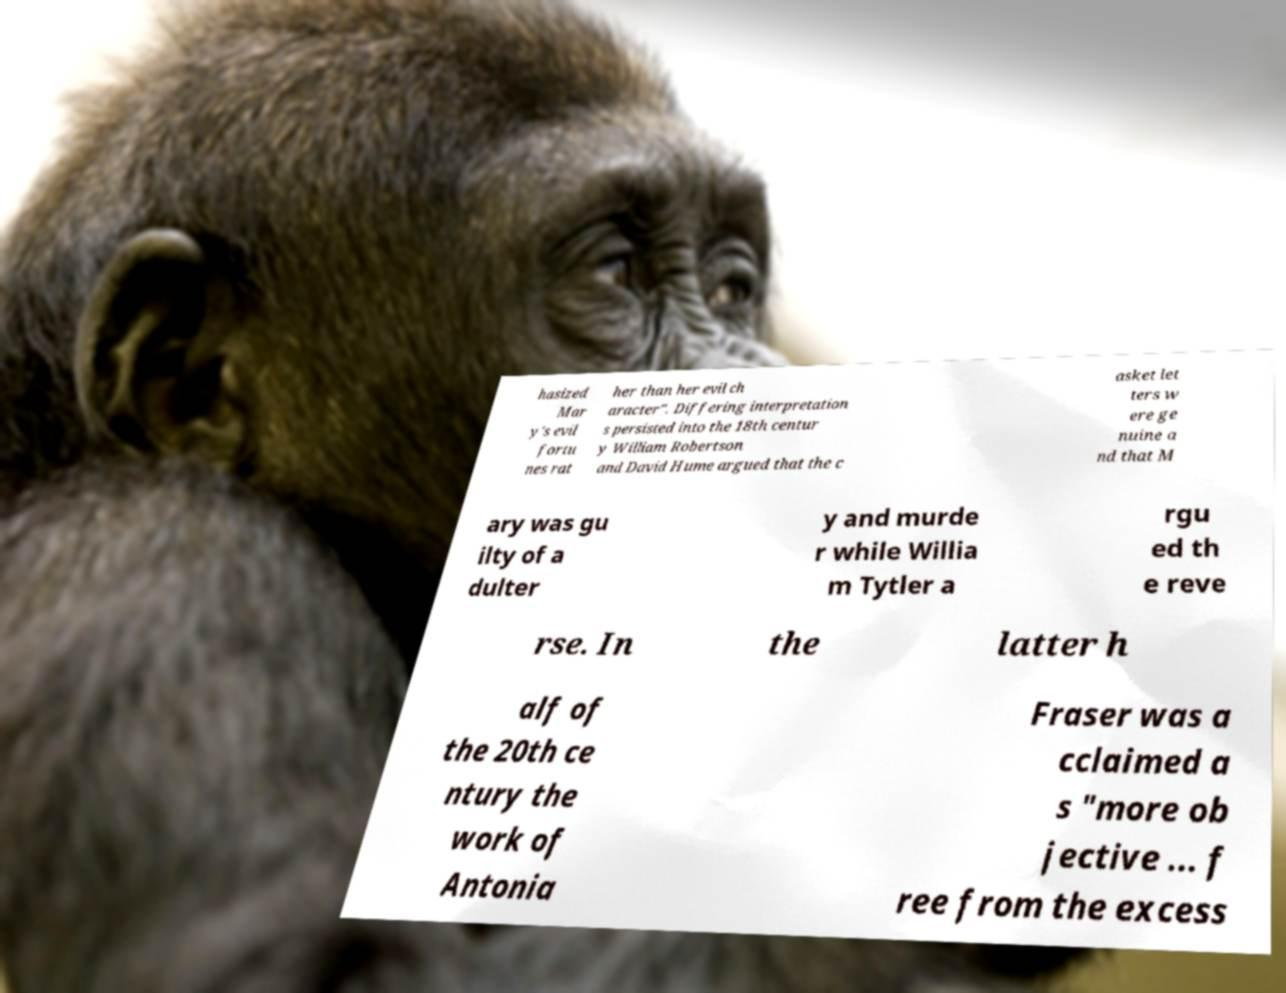Could you extract and type out the text from this image? hasized Mar y's evil fortu nes rat her than her evil ch aracter". Differing interpretation s persisted into the 18th centur y William Robertson and David Hume argued that the c asket let ters w ere ge nuine a nd that M ary was gu ilty of a dulter y and murde r while Willia m Tytler a rgu ed th e reve rse. In the latter h alf of the 20th ce ntury the work of Antonia Fraser was a cclaimed a s "more ob jective ... f ree from the excess 